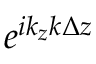<formula> <loc_0><loc_0><loc_500><loc_500>e ^ { i k _ { z } k \Delta z }</formula> 